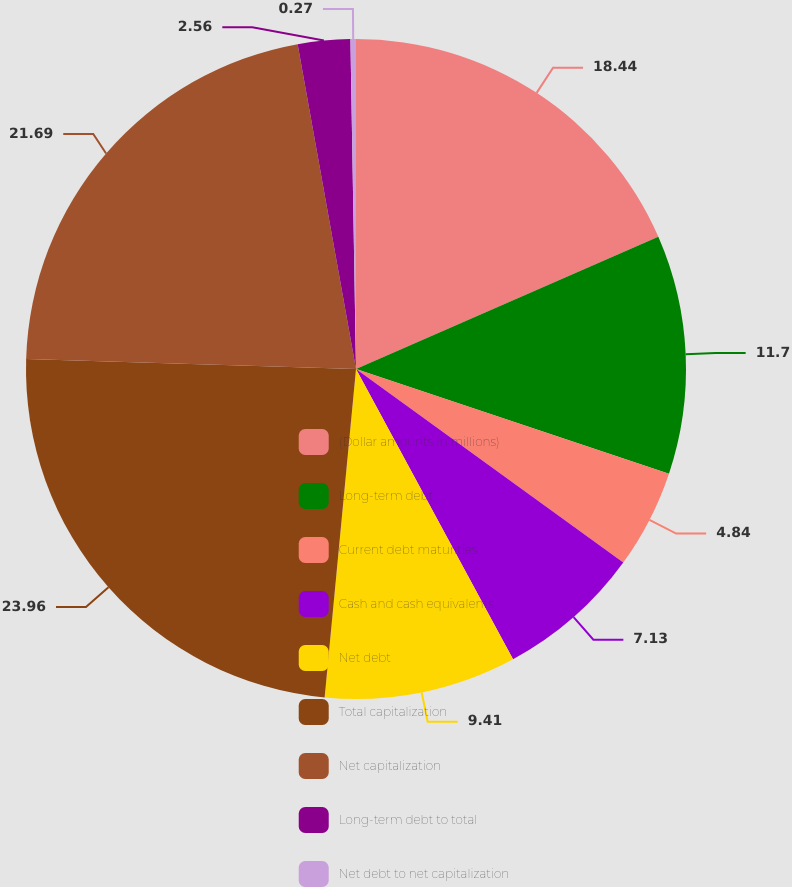Convert chart. <chart><loc_0><loc_0><loc_500><loc_500><pie_chart><fcel>(Dollar amounts in millions)<fcel>Long-term debt<fcel>Current debt maturities<fcel>Cash and cash equivalents<fcel>Net debt<fcel>Total capitalization<fcel>Net capitalization<fcel>Long-term debt to total<fcel>Net debt to net capitalization<nl><fcel>18.44%<fcel>11.7%<fcel>4.84%<fcel>7.13%<fcel>9.41%<fcel>23.97%<fcel>21.69%<fcel>2.56%<fcel>0.27%<nl></chart> 